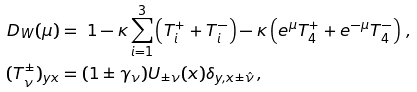Convert formula to latex. <formula><loc_0><loc_0><loc_500><loc_500>D _ { W } ( \mu ) & = \ 1 - \kappa \sum _ { i = 1 } ^ { 3 } \left ( T _ { i } ^ { + } + T _ { i } ^ { - } \right ) - \kappa \left ( e ^ { \mu } T _ { 4 } ^ { + } + e ^ { - \mu } T _ { 4 } ^ { - } \right ) \, , \\ ( T _ { \nu } ^ { \pm } ) _ { y x } & = ( 1 \pm \gamma _ { \nu } ) U _ { \pm \nu } ( x ) \delta _ { y , x \pm \hat { \nu } } \, ,</formula> 